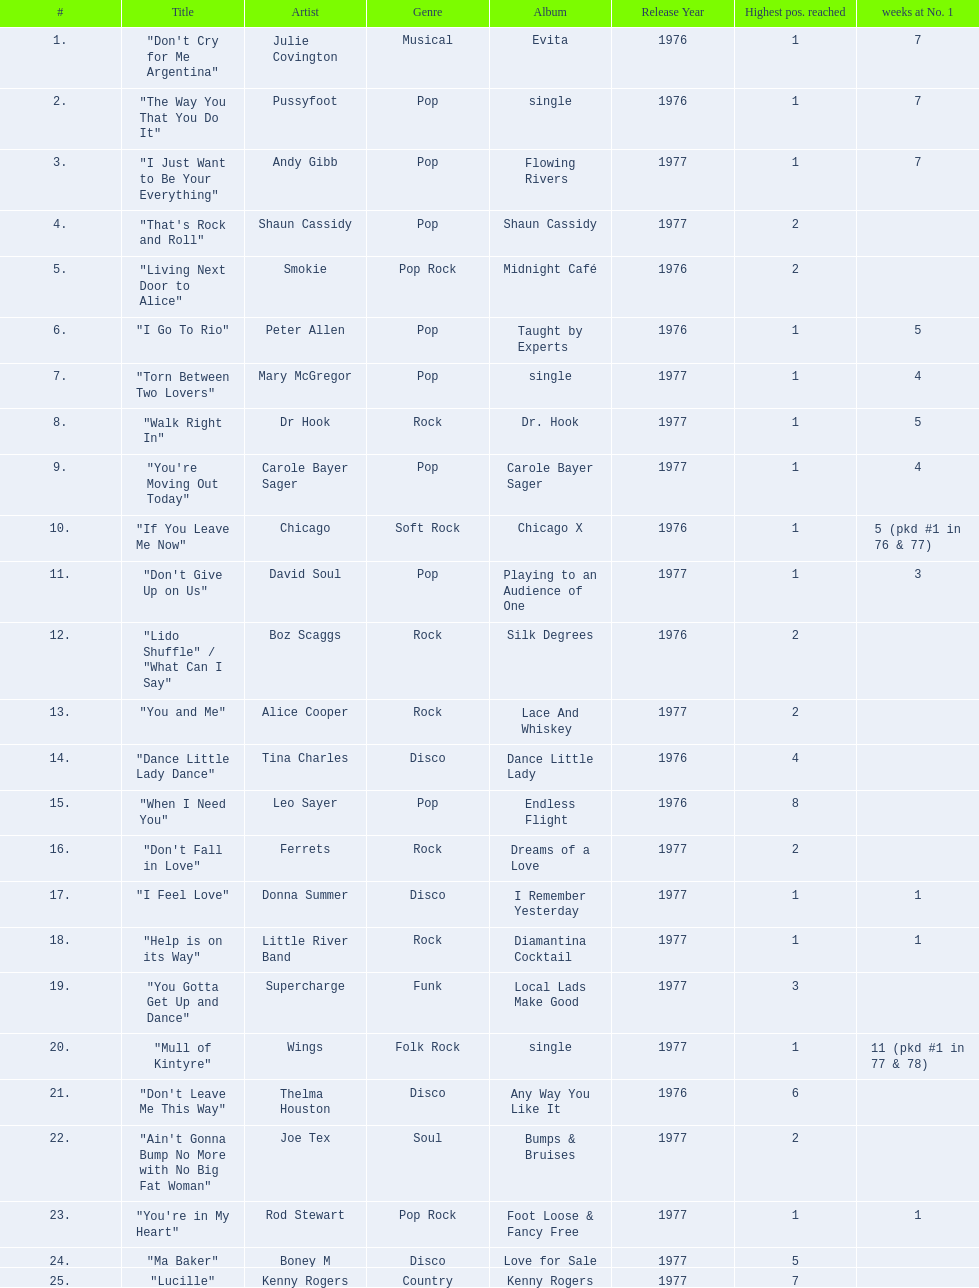How long is the longest amount of time spent at number 1? 11 (pkd #1 in 77 & 78). What song spent 11 weeks at number 1? "Mull of Kintyre". What band had a number 1 hit with this song? Wings. 